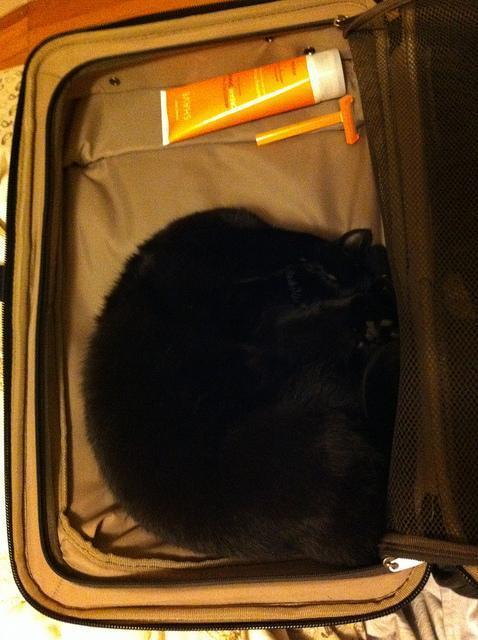How many items are in the bag?
Give a very brief answer. 3. 